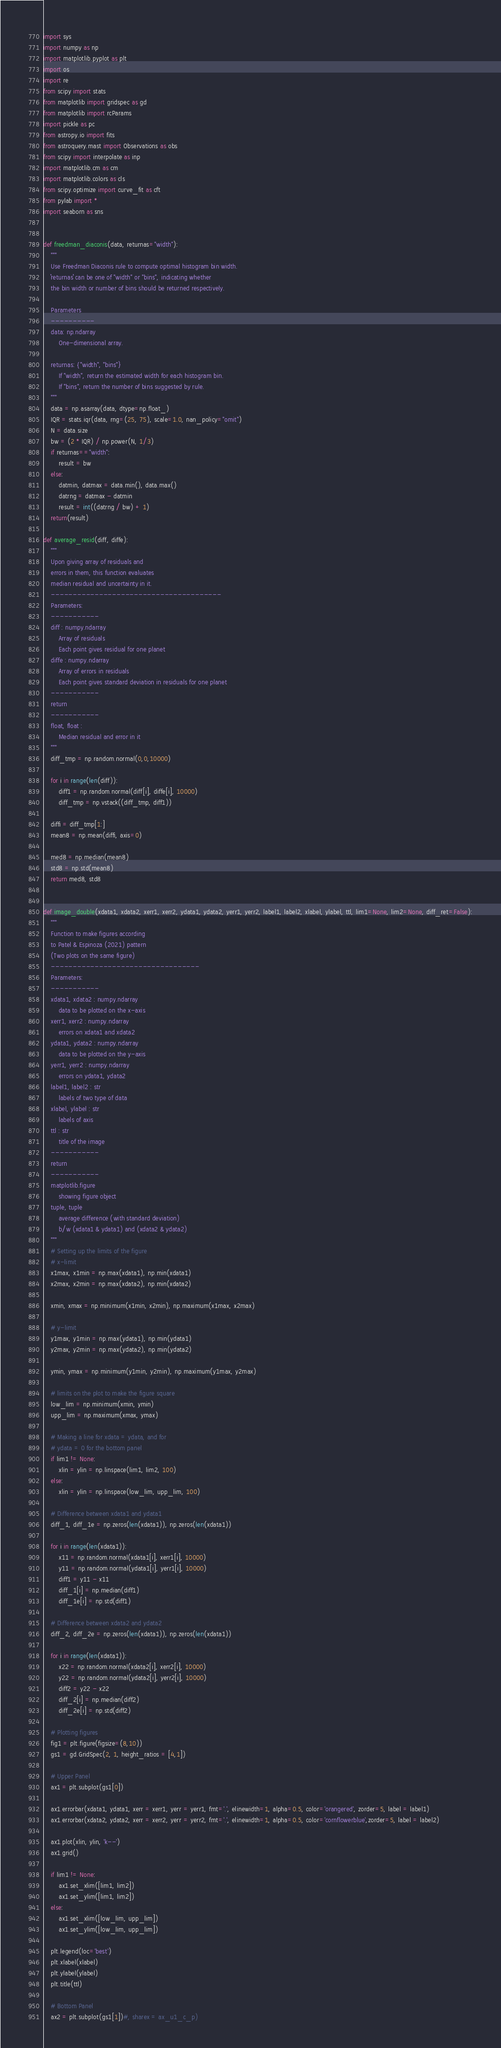Convert code to text. <code><loc_0><loc_0><loc_500><loc_500><_Python_>import sys
import numpy as np
import matplotlib.pyplot as plt
import os
import re
from scipy import stats
from matplotlib import gridspec as gd
from matplotlib import rcParams
import pickle as pc
from astropy.io import fits
from astroquery.mast import Observations as obs
from scipy import interpolate as inp
import matplotlib.cm as cm
import matplotlib.colors as cls
from scipy.optimize import curve_fit as cft
from pylab import *
import seaborn as sns


def freedman_diaconis(data, returnas="width"):
	"""
	Use Freedman Diaconis rule to compute optimal histogram bin width. 
	``returnas`` can be one of "width" or "bins", indicating whether
	the bin width or number of bins should be returned respectively.

	Parameters
	----------
	data: np.ndarray
		One-dimensional array.

	returnas: {"width", "bins"}
		If "width", return the estimated width for each histogram bin. 
		If "bins", return the number of bins suggested by rule.
	"""
	data = np.asarray(data, dtype=np.float_)
	IQR = stats.iqr(data, rng=(25, 75), scale=1.0, nan_policy="omit")
	N = data.size
	bw = (2 * IQR) / np.power(N, 1/3)
	if returnas=="width":
		result = bw
	else:
		datmin, datmax = data.min(), data.max()
		datrng = datmax - datmin
		result = int((datrng / bw) + 1)
	return(result)

def average_resid(diff, diffe):
    """
    Upon giving array of residuals and
    errors in them, this function evaluates
    median residual and uncertainty in it.
    ---------------------------------------
    Parameters:
    -----------
    diff : numpy.ndarray
        Array of residuals
        Each point gives residual for one planet
    diffe : numpy.ndarray
        Array of errors in residuals
        Each point gives standard deviation in residuals for one planet
    -----------
    return
    -----------
    float, float :
        Median residual and error in it
    """
    diff_tmp = np.random.normal(0,0,10000)

    for i in range(len(diff)):
        diff1 = np.random.normal(diff[i], diffe[i], 10000)
        diff_tmp = np.vstack((diff_tmp, diff1))

    diffi = diff_tmp[1:]
    mean8 = np.mean(diffi, axis=0)

    med8 = np.median(mean8)
    std8 = np.std(mean8)
    return med8, std8


def image_double(xdata1, xdata2, xerr1, xerr2, ydata1, ydata2, yerr1, yerr2, label1, label2, xlabel, ylabel, ttl, lim1=None, lim2=None, diff_ret=False):
    """
    Function to make figures according
    to Patel & Espinoza (2021) pattern
    (Two plots on the same figure)
    ----------------------------------
    Parameters:
    -----------
    xdata1, xdata2 : numpy.ndarray
        data to be plotted on the x-axis
    xerr1, xerr2 : numpy.ndarray
        errors on xdata1 and xdata2
    ydata1, ydata2 : numpy.ndarray
        data to be plotted on the y-axis
    yerr1, yerr2 : numpy.ndarray
        errors on ydata1, ydata2
    label1, label2 : str
        labels of two type of data
    xlabel, ylabel : str
        labels of axis
    ttl : str
        title of the image
    -----------
    return
    -----------
    matplotlib.figure
        showing figure object
    tuple, tuple
        average difference (with standard deviation)
        b/w (xdata1 & ydata1) and (xdata2 & ydata2)
    """
    # Setting up the limits of the figure
    # x-limit
    x1max, x1min = np.max(xdata1), np.min(xdata1)
    x2max, x2min = np.max(xdata2), np.min(xdata2)

    xmin, xmax = np.minimum(x1min, x2min), np.maximum(x1max, x2max)

    # y-limit
    y1max, y1min = np.max(ydata1), np.min(ydata1)
    y2max, y2min = np.max(ydata2), np.min(ydata2)

    ymin, ymax = np.minimum(y1min, y2min), np.maximum(y1max, y2max)

    # limits on the plot to make the figure square
    low_lim = np.minimum(xmin, ymin)
    upp_lim = np.maximum(xmax, ymax)

    # Making a line for xdata = ydata, and for
    # ydata = 0 for the bottom panel
    if lim1 != None:
        xlin = ylin = np.linspace(lim1, lim2, 100)
    else:
        xlin = ylin = np.linspace(low_lim, upp_lim, 100)

    # Difference between xdata1 and ydata1
    diff_1, diff_1e = np.zeros(len(xdata1)), np.zeros(len(xdata1))

    for i in range(len(xdata1)):
        x11 = np.random.normal(xdata1[i], xerr1[i], 10000)
        y11 = np.random.normal(ydata1[i], yerr1[i], 10000)
        diff1 = y11 - x11
        diff_1[i] = np.median(diff1)
        diff_1e[i] = np.std(diff1)

    # Difference between xdata2 and ydata2
    diff_2, diff_2e = np.zeros(len(xdata1)), np.zeros(len(xdata1))

    for i in range(len(xdata1)):
        x22 = np.random.normal(xdata2[i], xerr2[i], 10000)
        y22 = np.random.normal(ydata2[i], yerr2[i], 10000)
        diff2 = y22 - x22
        diff_2[i] = np.median(diff2)
        diff_2e[i] = np.std(diff2)

    # Plotting figures
    fig1 = plt.figure(figsize=(8,10))
    gs1 = gd.GridSpec(2, 1, height_ratios = [4,1])

    # Upper Panel
    ax1 = plt.subplot(gs1[0])

    ax1.errorbar(xdata1, ydata1, xerr = xerr1, yerr = yerr1, fmt='.', elinewidth=1, alpha=0.5, color='orangered', zorder=5, label = label1)
    ax1.errorbar(xdata2, ydata2, xerr = xerr2, yerr = yerr2, fmt='.', elinewidth=1, alpha=0.5, color='cornflowerblue',zorder=5, label = label2)

    ax1.plot(xlin, ylin, 'k--')
    ax1.grid()

    if lim1 != None:
        ax1.set_xlim([lim1, lim2])
        ax1.set_ylim([lim1, lim2])
    else:
        ax1.set_xlim([low_lim, upp_lim])
        ax1.set_ylim([low_lim, upp_lim])

    plt.legend(loc='best')
    plt.xlabel(xlabel)
    plt.ylabel(ylabel)
    plt.title(ttl)

    # Bottom Panel
    ax2 = plt.subplot(gs1[1])#, sharex = ax_u1_c_p)
</code> 